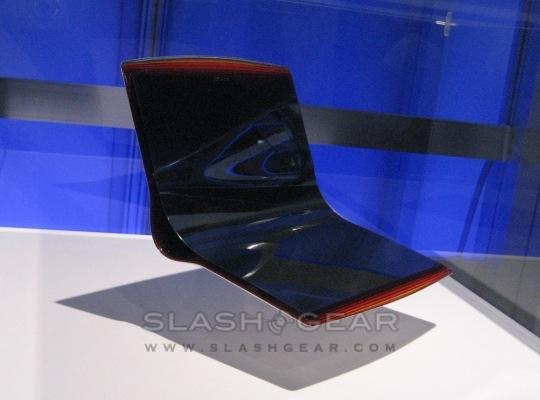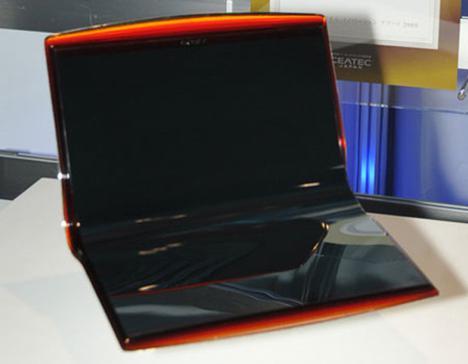The first image is the image on the left, the second image is the image on the right. Considering the images on both sides, is "The computer in the image on the left has a grey base." valid? Answer yes or no. No. 